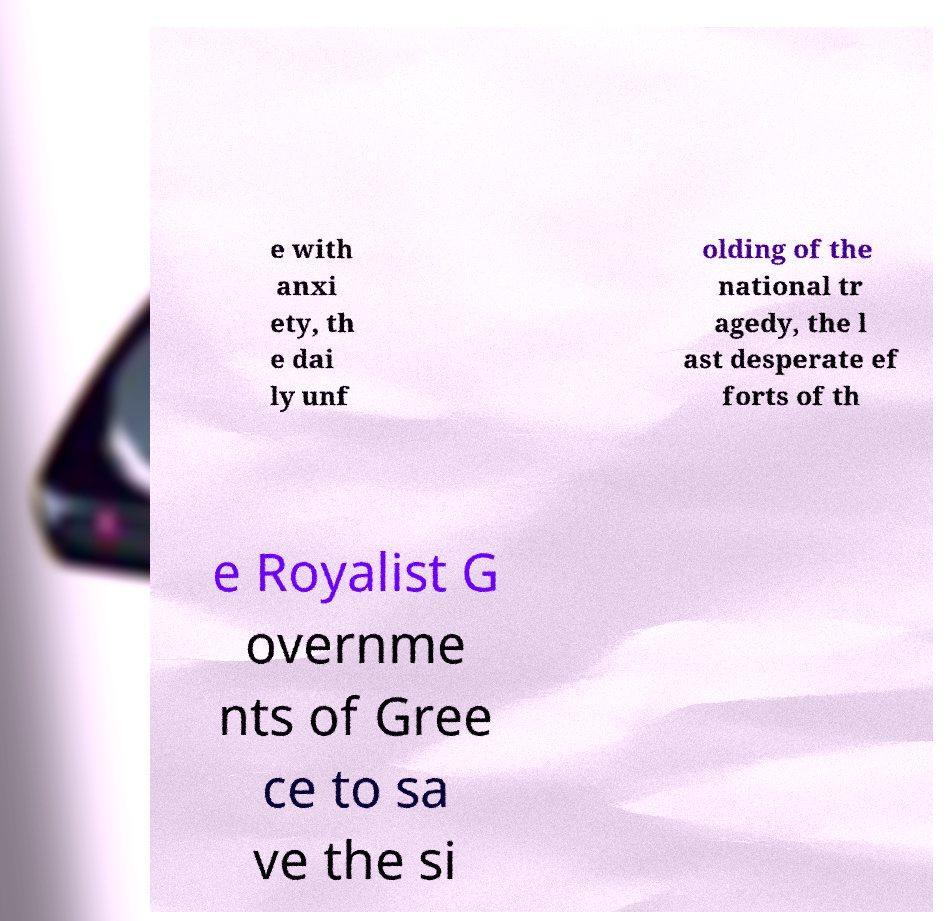Can you read and provide the text displayed in the image?This photo seems to have some interesting text. Can you extract and type it out for me? e with anxi ety, th e dai ly unf olding of the national tr agedy, the l ast desperate ef forts of th e Royalist G overnme nts of Gree ce to sa ve the si 